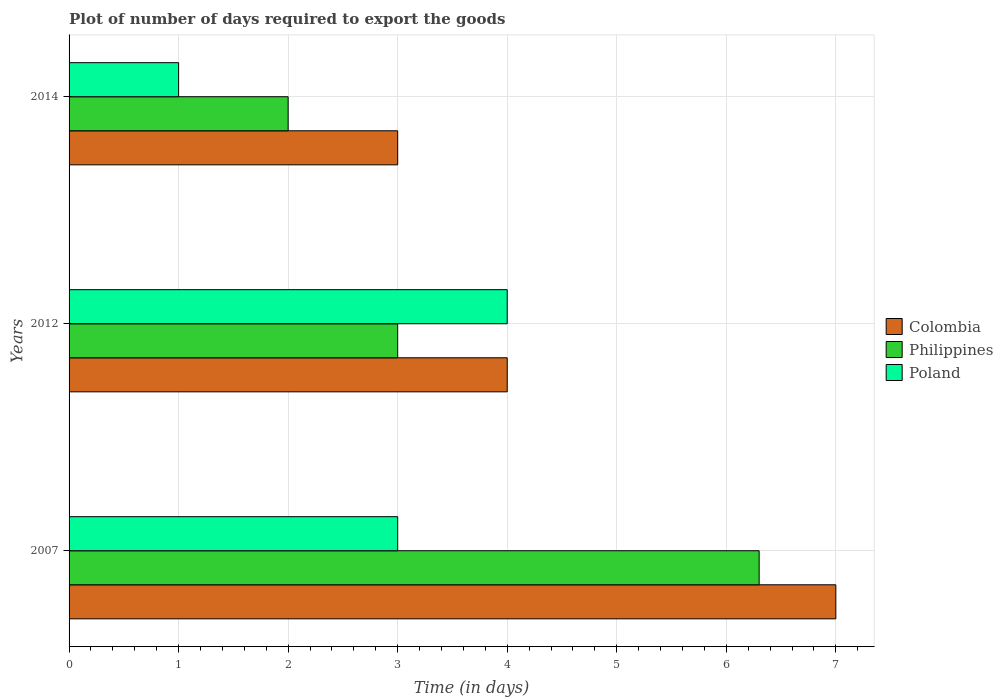How many different coloured bars are there?
Offer a terse response. 3. How many bars are there on the 3rd tick from the bottom?
Your answer should be very brief. 3. Across all years, what is the maximum time required to export goods in Philippines?
Provide a succinct answer. 6.3. Across all years, what is the minimum time required to export goods in Colombia?
Your response must be concise. 3. What is the average time required to export goods in Philippines per year?
Ensure brevity in your answer.  3.77. In the year 2007, what is the difference between the time required to export goods in Colombia and time required to export goods in Philippines?
Give a very brief answer. 0.7. What is the ratio of the time required to export goods in Poland in 2007 to that in 2012?
Keep it short and to the point. 0.75. Is the difference between the time required to export goods in Colombia in 2007 and 2012 greater than the difference between the time required to export goods in Philippines in 2007 and 2012?
Your answer should be very brief. No. What is the difference between the highest and the second highest time required to export goods in Poland?
Provide a short and direct response. 1. In how many years, is the time required to export goods in Philippines greater than the average time required to export goods in Philippines taken over all years?
Ensure brevity in your answer.  1. Is the sum of the time required to export goods in Philippines in 2012 and 2014 greater than the maximum time required to export goods in Colombia across all years?
Make the answer very short. No. What does the 3rd bar from the bottom in 2014 represents?
Keep it short and to the point. Poland. Is it the case that in every year, the sum of the time required to export goods in Philippines and time required to export goods in Colombia is greater than the time required to export goods in Poland?
Ensure brevity in your answer.  Yes. Are all the bars in the graph horizontal?
Provide a short and direct response. Yes. What is the difference between two consecutive major ticks on the X-axis?
Your response must be concise. 1. Are the values on the major ticks of X-axis written in scientific E-notation?
Make the answer very short. No. Does the graph contain any zero values?
Your answer should be very brief. No. How many legend labels are there?
Keep it short and to the point. 3. How are the legend labels stacked?
Ensure brevity in your answer.  Vertical. What is the title of the graph?
Your answer should be compact. Plot of number of days required to export the goods. What is the label or title of the X-axis?
Offer a terse response. Time (in days). What is the label or title of the Y-axis?
Offer a terse response. Years. What is the Time (in days) of Philippines in 2007?
Ensure brevity in your answer.  6.3. What is the Time (in days) in Poland in 2007?
Your response must be concise. 3. What is the Time (in days) of Colombia in 2014?
Provide a short and direct response. 3. Across all years, what is the maximum Time (in days) of Philippines?
Offer a very short reply. 6.3. Across all years, what is the maximum Time (in days) in Poland?
Provide a short and direct response. 4. What is the total Time (in days) of Colombia in the graph?
Your answer should be very brief. 14. What is the total Time (in days) in Philippines in the graph?
Make the answer very short. 11.3. What is the total Time (in days) of Poland in the graph?
Make the answer very short. 8. What is the difference between the Time (in days) in Poland in 2007 and that in 2012?
Provide a succinct answer. -1. What is the difference between the Time (in days) of Colombia in 2007 and that in 2014?
Provide a short and direct response. 4. What is the difference between the Time (in days) in Philippines in 2007 and that in 2014?
Keep it short and to the point. 4.3. What is the difference between the Time (in days) of Poland in 2007 and that in 2014?
Keep it short and to the point. 2. What is the difference between the Time (in days) of Philippines in 2012 and that in 2014?
Give a very brief answer. 1. What is the difference between the Time (in days) in Poland in 2012 and that in 2014?
Make the answer very short. 3. What is the difference between the Time (in days) in Colombia in 2007 and the Time (in days) in Poland in 2012?
Keep it short and to the point. 3. What is the difference between the Time (in days) of Colombia in 2012 and the Time (in days) of Poland in 2014?
Keep it short and to the point. 3. What is the difference between the Time (in days) of Philippines in 2012 and the Time (in days) of Poland in 2014?
Keep it short and to the point. 2. What is the average Time (in days) in Colombia per year?
Offer a terse response. 4.67. What is the average Time (in days) in Philippines per year?
Ensure brevity in your answer.  3.77. What is the average Time (in days) in Poland per year?
Ensure brevity in your answer.  2.67. In the year 2007, what is the difference between the Time (in days) in Philippines and Time (in days) in Poland?
Your answer should be very brief. 3.3. In the year 2012, what is the difference between the Time (in days) of Colombia and Time (in days) of Philippines?
Provide a succinct answer. 1. In the year 2012, what is the difference between the Time (in days) in Colombia and Time (in days) in Poland?
Your answer should be very brief. 0. In the year 2012, what is the difference between the Time (in days) in Philippines and Time (in days) in Poland?
Make the answer very short. -1. In the year 2014, what is the difference between the Time (in days) in Colombia and Time (in days) in Philippines?
Keep it short and to the point. 1. In the year 2014, what is the difference between the Time (in days) in Philippines and Time (in days) in Poland?
Keep it short and to the point. 1. What is the ratio of the Time (in days) in Philippines in 2007 to that in 2012?
Make the answer very short. 2.1. What is the ratio of the Time (in days) in Poland in 2007 to that in 2012?
Ensure brevity in your answer.  0.75. What is the ratio of the Time (in days) of Colombia in 2007 to that in 2014?
Offer a very short reply. 2.33. What is the ratio of the Time (in days) of Philippines in 2007 to that in 2014?
Make the answer very short. 3.15. What is the ratio of the Time (in days) in Philippines in 2012 to that in 2014?
Make the answer very short. 1.5. What is the difference between the highest and the second highest Time (in days) of Colombia?
Ensure brevity in your answer.  3. What is the difference between the highest and the second highest Time (in days) in Philippines?
Give a very brief answer. 3.3. What is the difference between the highest and the second highest Time (in days) in Poland?
Offer a very short reply. 1. What is the difference between the highest and the lowest Time (in days) in Philippines?
Provide a short and direct response. 4.3. What is the difference between the highest and the lowest Time (in days) of Poland?
Offer a terse response. 3. 